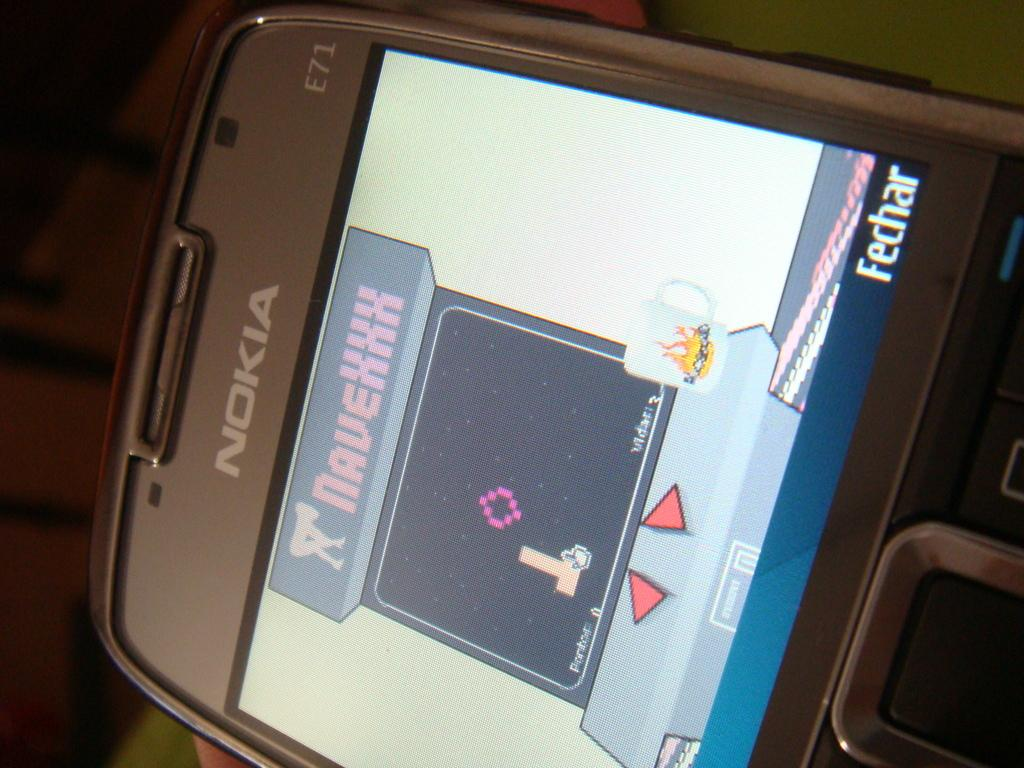<image>
Create a compact narrative representing the image presented. A Nokia E71 phone depicts a game being played. 